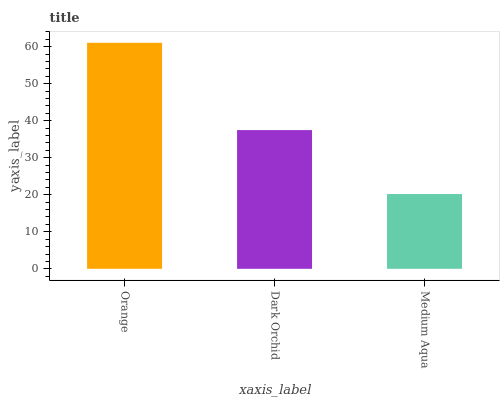Is Medium Aqua the minimum?
Answer yes or no. Yes. Is Orange the maximum?
Answer yes or no. Yes. Is Dark Orchid the minimum?
Answer yes or no. No. Is Dark Orchid the maximum?
Answer yes or no. No. Is Orange greater than Dark Orchid?
Answer yes or no. Yes. Is Dark Orchid less than Orange?
Answer yes or no. Yes. Is Dark Orchid greater than Orange?
Answer yes or no. No. Is Orange less than Dark Orchid?
Answer yes or no. No. Is Dark Orchid the high median?
Answer yes or no. Yes. Is Dark Orchid the low median?
Answer yes or no. Yes. Is Medium Aqua the high median?
Answer yes or no. No. Is Medium Aqua the low median?
Answer yes or no. No. 